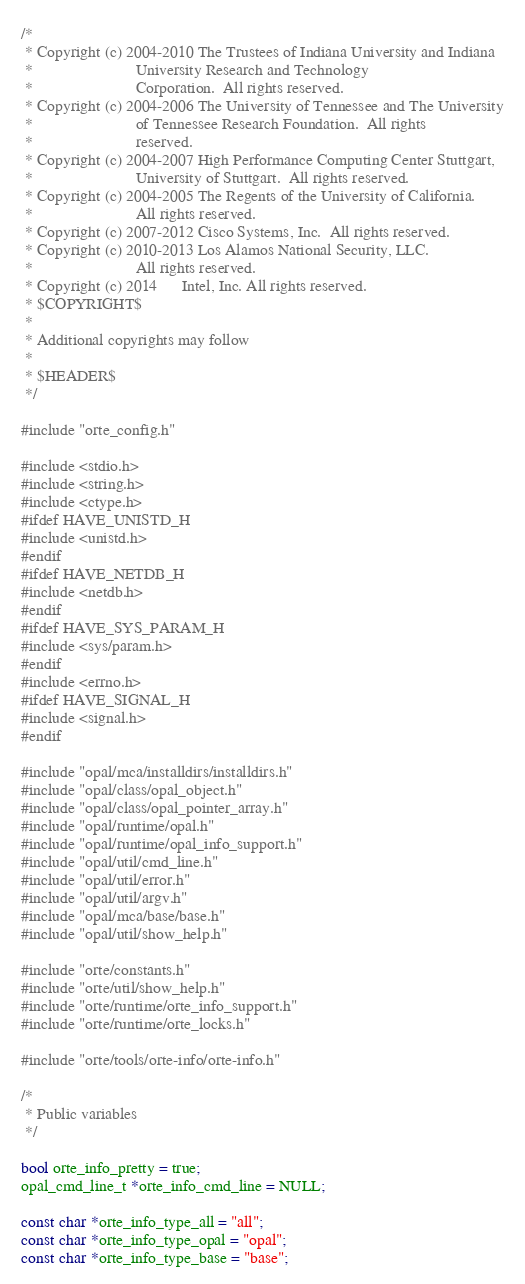Convert code to text. <code><loc_0><loc_0><loc_500><loc_500><_C_>/*
 * Copyright (c) 2004-2010 The Trustees of Indiana University and Indiana
 *                         University Research and Technology
 *                         Corporation.  All rights reserved.
 * Copyright (c) 2004-2006 The University of Tennessee and The University
 *                         of Tennessee Research Foundation.  All rights
 *                         reserved.
 * Copyright (c) 2004-2007 High Performance Computing Center Stuttgart, 
 *                         University of Stuttgart.  All rights reserved.
 * Copyright (c) 2004-2005 The Regents of the University of California.
 *                         All rights reserved.
 * Copyright (c) 2007-2012 Cisco Systems, Inc.  All rights reserved.
 * Copyright (c) 2010-2013 Los Alamos National Security, LLC.
 *                         All rights reserved.
 * Copyright (c) 2014      Intel, Inc. All rights reserved.
 * $COPYRIGHT$
 * 
 * Additional copyrights may follow
 * 
 * $HEADER$
 */

#include "orte_config.h"

#include <stdio.h>
#include <string.h>
#include <ctype.h>
#ifdef HAVE_UNISTD_H
#include <unistd.h>
#endif
#ifdef HAVE_NETDB_H
#include <netdb.h>
#endif
#ifdef HAVE_SYS_PARAM_H
#include <sys/param.h>
#endif
#include <errno.h>
#ifdef HAVE_SIGNAL_H
#include <signal.h>
#endif

#include "opal/mca/installdirs/installdirs.h"
#include "opal/class/opal_object.h"
#include "opal/class/opal_pointer_array.h"
#include "opal/runtime/opal.h"
#include "opal/runtime/opal_info_support.h"
#include "opal/util/cmd_line.h"
#include "opal/util/error.h"
#include "opal/util/argv.h"
#include "opal/mca/base/base.h"
#include "opal/util/show_help.h"

#include "orte/constants.h"
#include "orte/util/show_help.h"
#include "orte/runtime/orte_info_support.h"
#include "orte/runtime/orte_locks.h"

#include "orte/tools/orte-info/orte-info.h"

/*
 * Public variables
 */

bool orte_info_pretty = true;
opal_cmd_line_t *orte_info_cmd_line = NULL;

const char *orte_info_type_all = "all";
const char *orte_info_type_opal = "opal";
const char *orte_info_type_base = "base";
</code> 